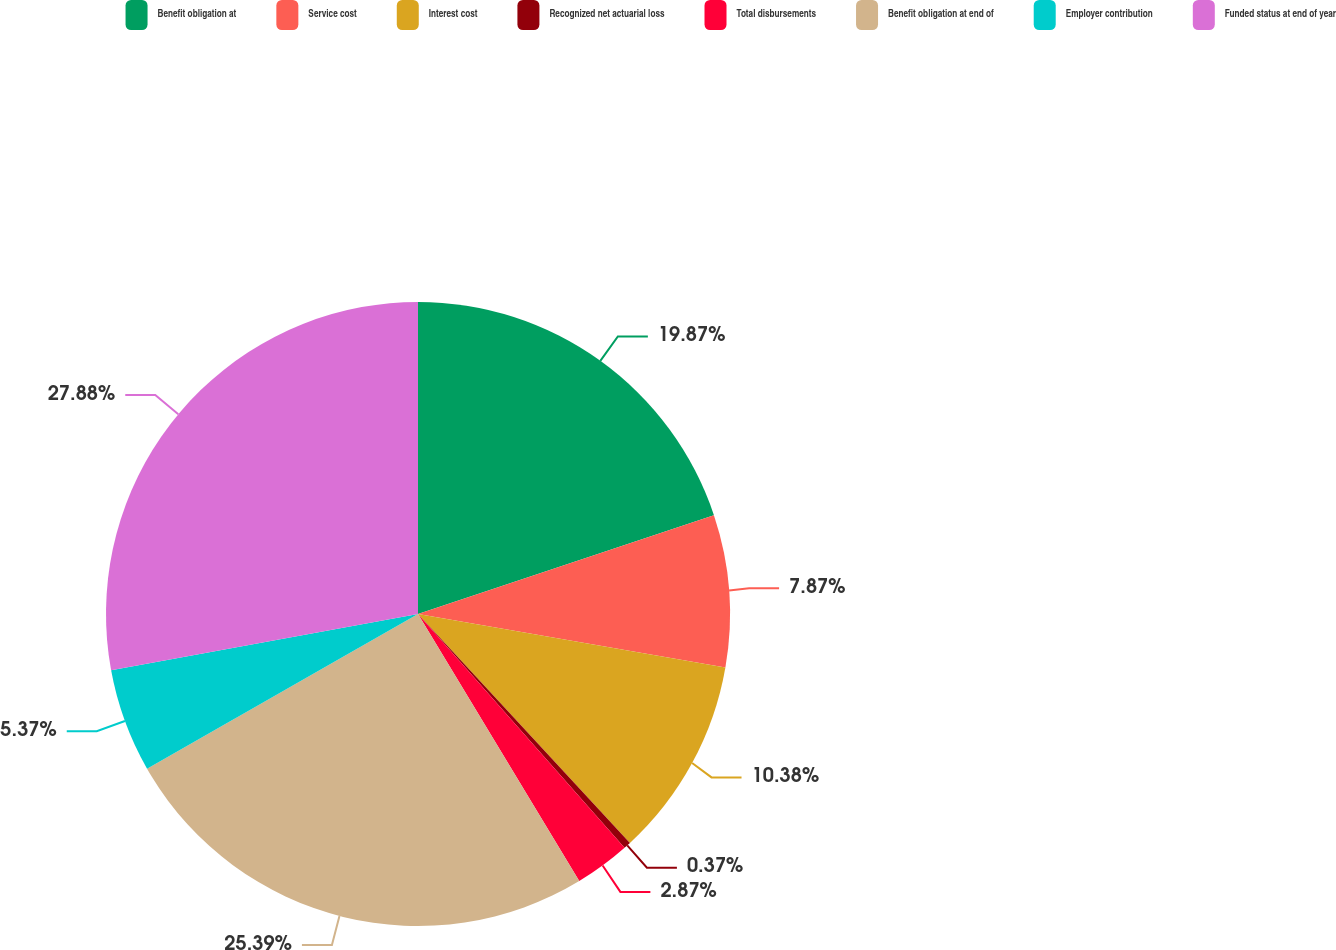Convert chart. <chart><loc_0><loc_0><loc_500><loc_500><pie_chart><fcel>Benefit obligation at<fcel>Service cost<fcel>Interest cost<fcel>Recognized net actuarial loss<fcel>Total disbursements<fcel>Benefit obligation at end of<fcel>Employer contribution<fcel>Funded status at end of year<nl><fcel>19.87%<fcel>7.87%<fcel>10.38%<fcel>0.37%<fcel>2.87%<fcel>25.39%<fcel>5.37%<fcel>27.89%<nl></chart> 